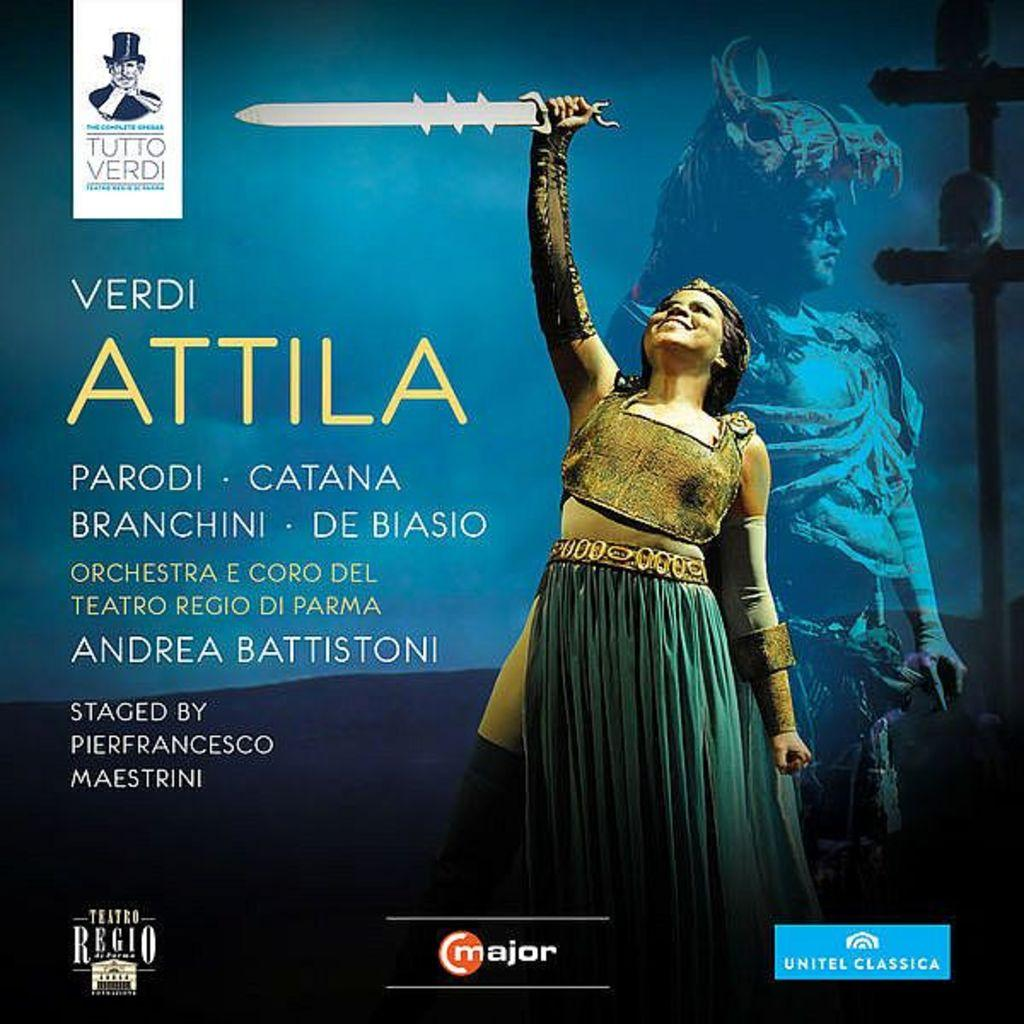Who is present in the image? There is a woman in the image. What is the woman wearing? The woman is wearing clothes. What object is the woman holding in her hand? The woman is holding a sword in her hand. How is the text in the image presented? The text in the image appears to be printed. What type of powder can be seen on the mountain in the image? There is no mountain or powder present in the image. 